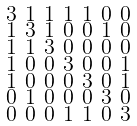<formula> <loc_0><loc_0><loc_500><loc_500>\begin{smallmatrix} 3 & 1 & 1 & 1 & 1 & 0 & 0 \\ 1 & 3 & 1 & 0 & 0 & 1 & 0 \\ 1 & 1 & 3 & 0 & 0 & 0 & 0 \\ 1 & 0 & 0 & 3 & 0 & 0 & 1 \\ 1 & 0 & 0 & 0 & 3 & 0 & 1 \\ 0 & 1 & 0 & 0 & 0 & 3 & 0 \\ 0 & 0 & 0 & 1 & 1 & 0 & 3 \end{smallmatrix}</formula> 